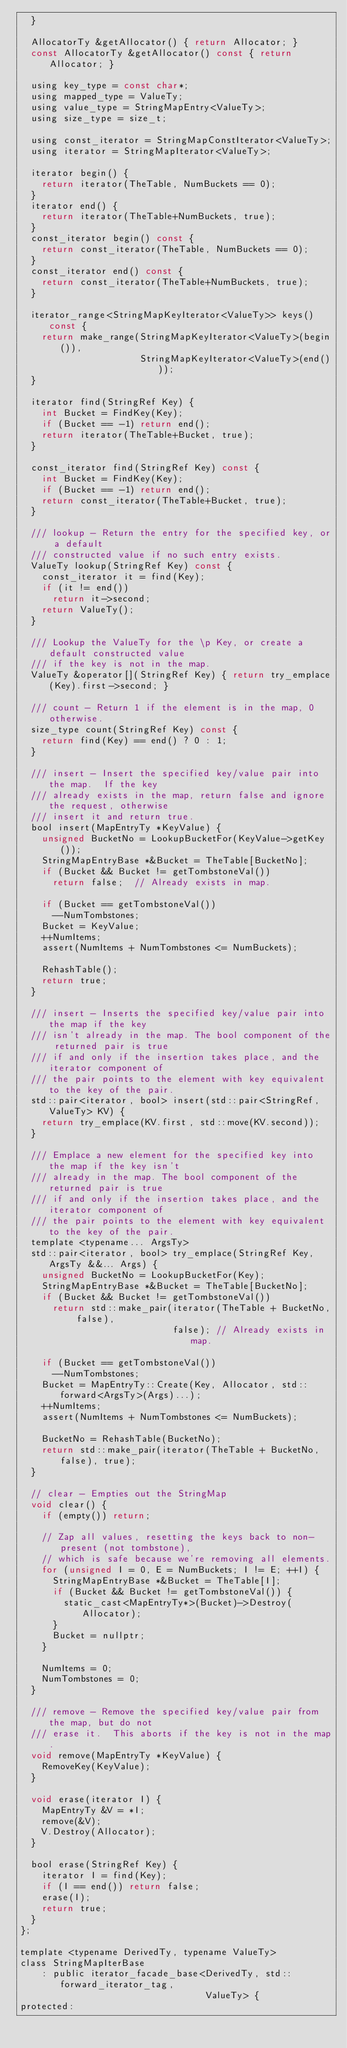<code> <loc_0><loc_0><loc_500><loc_500><_C_>  }

  AllocatorTy &getAllocator() { return Allocator; }
  const AllocatorTy &getAllocator() const { return Allocator; }

  using key_type = const char*;
  using mapped_type = ValueTy;
  using value_type = StringMapEntry<ValueTy>;
  using size_type = size_t;

  using const_iterator = StringMapConstIterator<ValueTy>;
  using iterator = StringMapIterator<ValueTy>;

  iterator begin() {
    return iterator(TheTable, NumBuckets == 0);
  }
  iterator end() {
    return iterator(TheTable+NumBuckets, true);
  }
  const_iterator begin() const {
    return const_iterator(TheTable, NumBuckets == 0);
  }
  const_iterator end() const {
    return const_iterator(TheTable+NumBuckets, true);
  }

  iterator_range<StringMapKeyIterator<ValueTy>> keys() const {
    return make_range(StringMapKeyIterator<ValueTy>(begin()),
                      StringMapKeyIterator<ValueTy>(end()));
  }

  iterator find(StringRef Key) {
    int Bucket = FindKey(Key);
    if (Bucket == -1) return end();
    return iterator(TheTable+Bucket, true);
  }

  const_iterator find(StringRef Key) const {
    int Bucket = FindKey(Key);
    if (Bucket == -1) return end();
    return const_iterator(TheTable+Bucket, true);
  }

  /// lookup - Return the entry for the specified key, or a default
  /// constructed value if no such entry exists.
  ValueTy lookup(StringRef Key) const {
    const_iterator it = find(Key);
    if (it != end())
      return it->second;
    return ValueTy();
  }

  /// Lookup the ValueTy for the \p Key, or create a default constructed value
  /// if the key is not in the map.
  ValueTy &operator[](StringRef Key) { return try_emplace(Key).first->second; }

  /// count - Return 1 if the element is in the map, 0 otherwise.
  size_type count(StringRef Key) const {
    return find(Key) == end() ? 0 : 1;
  }

  /// insert - Insert the specified key/value pair into the map.  If the key
  /// already exists in the map, return false and ignore the request, otherwise
  /// insert it and return true.
  bool insert(MapEntryTy *KeyValue) {
    unsigned BucketNo = LookupBucketFor(KeyValue->getKey());
    StringMapEntryBase *&Bucket = TheTable[BucketNo];
    if (Bucket && Bucket != getTombstoneVal())
      return false;  // Already exists in map.

    if (Bucket == getTombstoneVal())
      --NumTombstones;
    Bucket = KeyValue;
    ++NumItems;
    assert(NumItems + NumTombstones <= NumBuckets);

    RehashTable();
    return true;
  }

  /// insert - Inserts the specified key/value pair into the map if the key
  /// isn't already in the map. The bool component of the returned pair is true
  /// if and only if the insertion takes place, and the iterator component of
  /// the pair points to the element with key equivalent to the key of the pair.
  std::pair<iterator, bool> insert(std::pair<StringRef, ValueTy> KV) {
    return try_emplace(KV.first, std::move(KV.second));
  }

  /// Emplace a new element for the specified key into the map if the key isn't
  /// already in the map. The bool component of the returned pair is true
  /// if and only if the insertion takes place, and the iterator component of
  /// the pair points to the element with key equivalent to the key of the pair.
  template <typename... ArgsTy>
  std::pair<iterator, bool> try_emplace(StringRef Key, ArgsTy &&... Args) {
    unsigned BucketNo = LookupBucketFor(Key);
    StringMapEntryBase *&Bucket = TheTable[BucketNo];
    if (Bucket && Bucket != getTombstoneVal())
      return std::make_pair(iterator(TheTable + BucketNo, false),
                            false); // Already exists in map.

    if (Bucket == getTombstoneVal())
      --NumTombstones;
    Bucket = MapEntryTy::Create(Key, Allocator, std::forward<ArgsTy>(Args)...);
    ++NumItems;
    assert(NumItems + NumTombstones <= NumBuckets);

    BucketNo = RehashTable(BucketNo);
    return std::make_pair(iterator(TheTable + BucketNo, false), true);
  }

  // clear - Empties out the StringMap
  void clear() {
    if (empty()) return;

    // Zap all values, resetting the keys back to non-present (not tombstone),
    // which is safe because we're removing all elements.
    for (unsigned I = 0, E = NumBuckets; I != E; ++I) {
      StringMapEntryBase *&Bucket = TheTable[I];
      if (Bucket && Bucket != getTombstoneVal()) {
        static_cast<MapEntryTy*>(Bucket)->Destroy(Allocator);
      }
      Bucket = nullptr;
    }

    NumItems = 0;
    NumTombstones = 0;
  }

  /// remove - Remove the specified key/value pair from the map, but do not
  /// erase it.  This aborts if the key is not in the map.
  void remove(MapEntryTy *KeyValue) {
    RemoveKey(KeyValue);
  }

  void erase(iterator I) {
    MapEntryTy &V = *I;
    remove(&V);
    V.Destroy(Allocator);
  }

  bool erase(StringRef Key) {
    iterator I = find(Key);
    if (I == end()) return false;
    erase(I);
    return true;
  }
};

template <typename DerivedTy, typename ValueTy>
class StringMapIterBase
    : public iterator_facade_base<DerivedTy, std::forward_iterator_tag,
                                  ValueTy> {
protected:</code> 